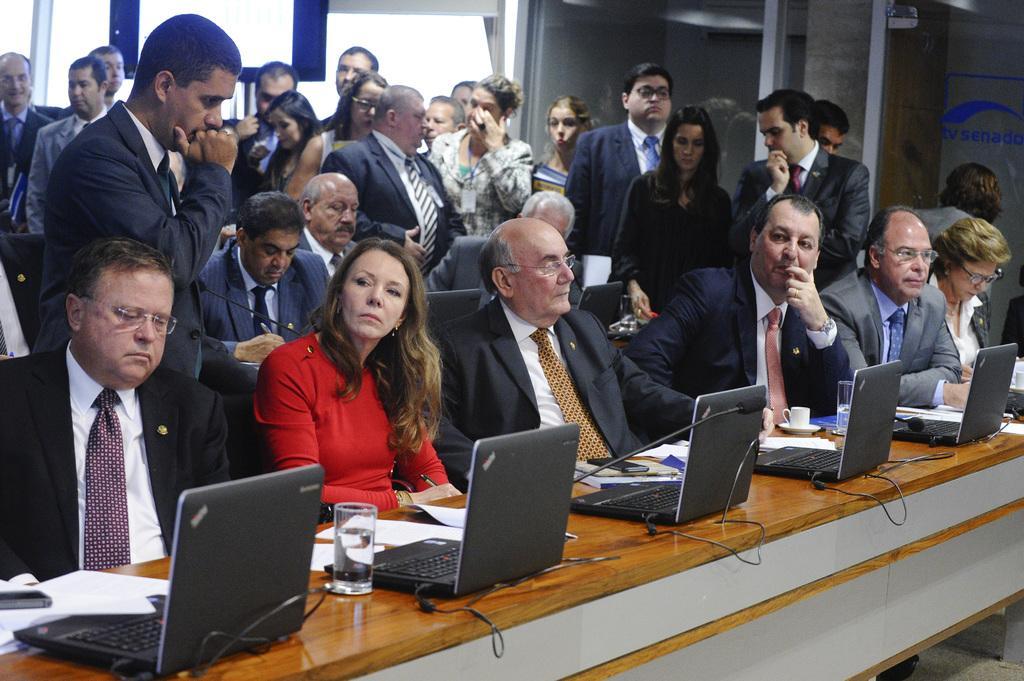Could you give a brief overview of what you see in this image? In this image few persons are sitting on the chairs. Bottom of the image there is a table having few laptops, glasses, cup and saucer and few objects on it. Behind the table there are few persons wearing suit and tie. Few persons are standing, behind them there is a wall. 